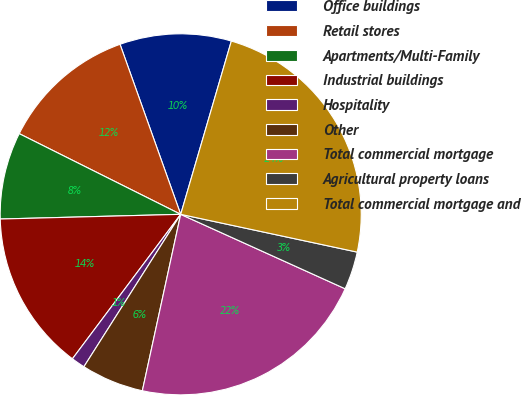<chart> <loc_0><loc_0><loc_500><loc_500><pie_chart><fcel>Office buildings<fcel>Retail stores<fcel>Apartments/Multi-Family<fcel>Industrial buildings<fcel>Hospitality<fcel>Other<fcel>Total commercial mortgage<fcel>Agricultural property loans<fcel>Total commercial mortgage and<nl><fcel>9.98%<fcel>12.17%<fcel>7.79%<fcel>14.35%<fcel>1.23%<fcel>5.6%<fcel>21.64%<fcel>3.41%<fcel>23.83%<nl></chart> 